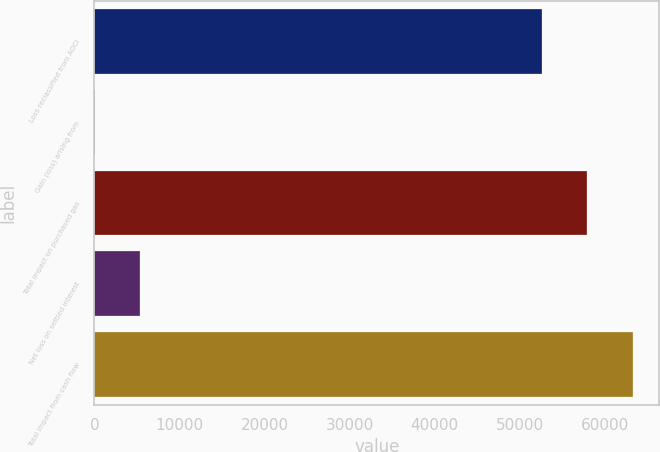<chart> <loc_0><loc_0><loc_500><loc_500><bar_chart><fcel>Loss reclassified from AOCI<fcel>Gain (loss) arising from<fcel>Total impact on purchased gas<fcel>Net loss on settled interest<fcel>Total impact from cash flow<nl><fcel>52651<fcel>19<fcel>57970.7<fcel>5338.7<fcel>63290.4<nl></chart> 